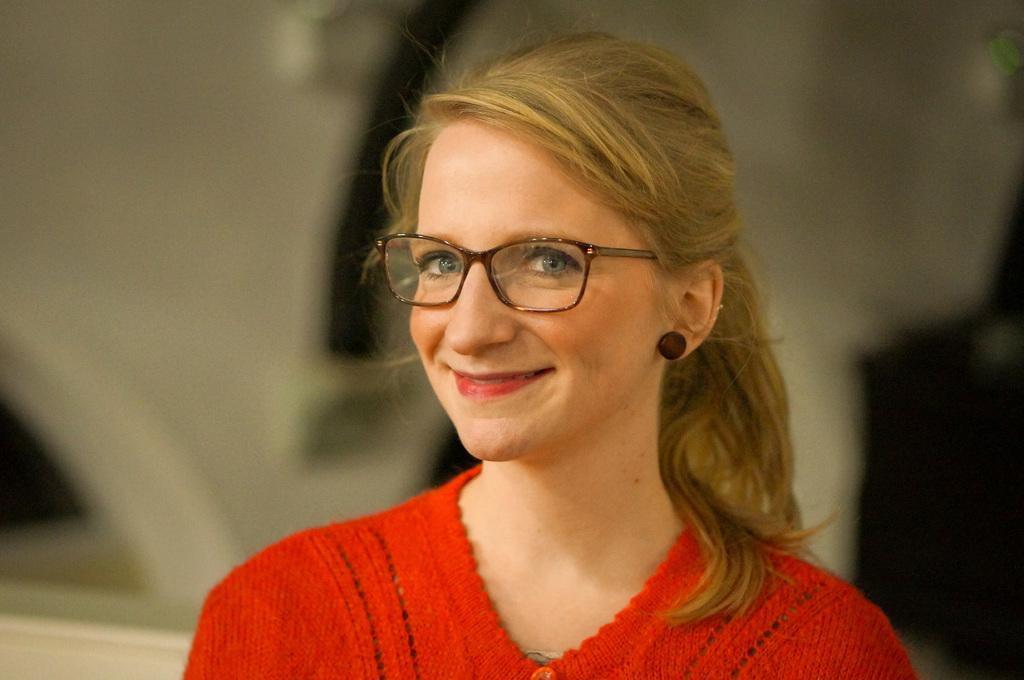What is the main subject of the image? The main subject of the image is a lady. What is the lady wearing in the image? The lady is wearing a red dress in the image. What is the lady's facial expression in the image? The lady is smiling in the image. What type of lock can be seen on the lady's red dress in the image? There is no lock present on the lady's red dress in the image. 